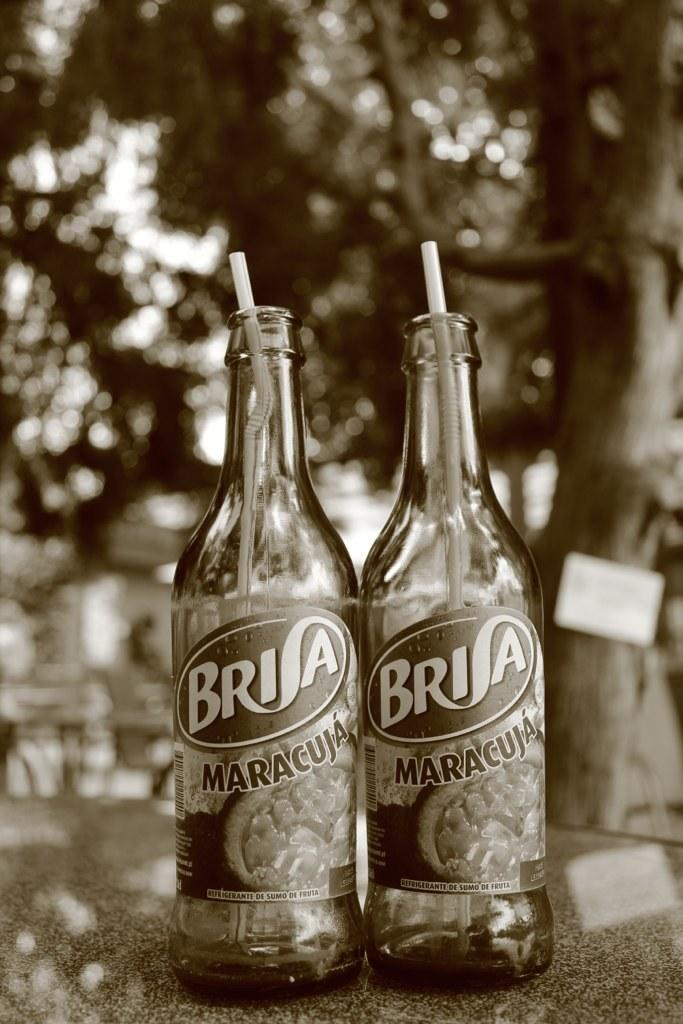Provide a one-sentence caption for the provided image. Two bottles of Brisa with straws in them outdoors by a tree. 